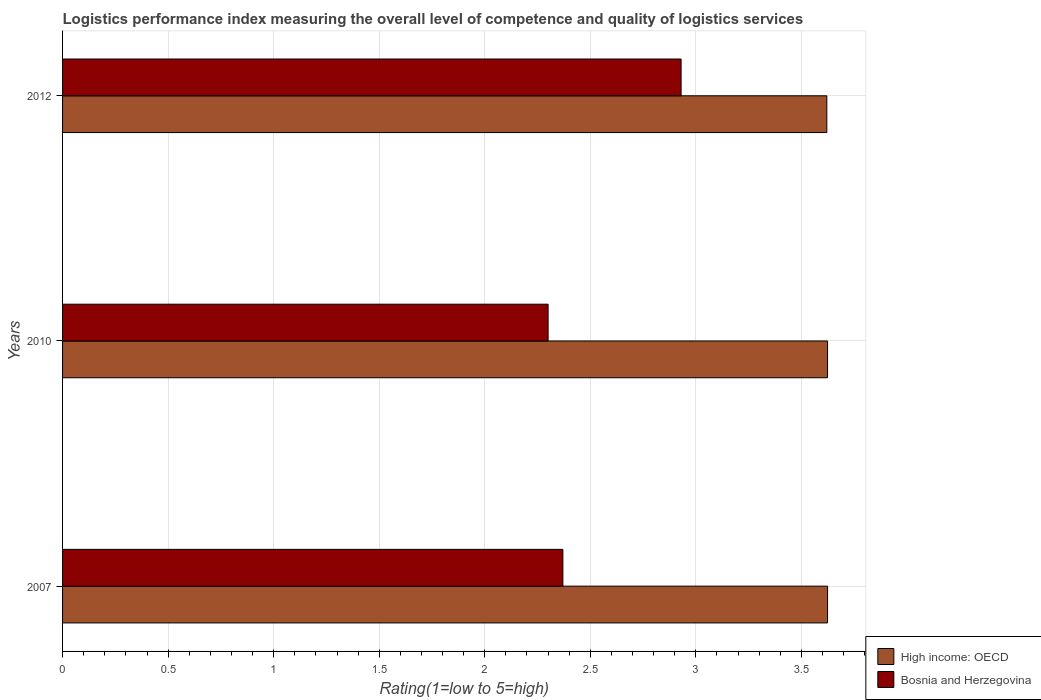Are the number of bars per tick equal to the number of legend labels?
Your answer should be very brief. Yes. What is the label of the 2nd group of bars from the top?
Give a very brief answer. 2010. What is the Logistic performance index in High income: OECD in 2007?
Your response must be concise. 3.62. Across all years, what is the maximum Logistic performance index in High income: OECD?
Give a very brief answer. 3.62. Across all years, what is the minimum Logistic performance index in Bosnia and Herzegovina?
Give a very brief answer. 2.3. What is the difference between the Logistic performance index in High income: OECD in 2010 and that in 2012?
Offer a terse response. 0. What is the difference between the Logistic performance index in Bosnia and Herzegovina in 2010 and the Logistic performance index in High income: OECD in 2007?
Keep it short and to the point. -1.32. What is the average Logistic performance index in Bosnia and Herzegovina per year?
Provide a succinct answer. 2.53. In the year 2010, what is the difference between the Logistic performance index in Bosnia and Herzegovina and Logistic performance index in High income: OECD?
Offer a terse response. -1.32. In how many years, is the Logistic performance index in Bosnia and Herzegovina greater than 3.1 ?
Provide a short and direct response. 0. What is the ratio of the Logistic performance index in High income: OECD in 2007 to that in 2010?
Provide a succinct answer. 1. Is the difference between the Logistic performance index in Bosnia and Herzegovina in 2010 and 2012 greater than the difference between the Logistic performance index in High income: OECD in 2010 and 2012?
Offer a very short reply. No. What is the difference between the highest and the second highest Logistic performance index in Bosnia and Herzegovina?
Make the answer very short. 0.56. What is the difference between the highest and the lowest Logistic performance index in High income: OECD?
Make the answer very short. 0. What does the 2nd bar from the top in 2012 represents?
Provide a succinct answer. High income: OECD. What does the 1st bar from the bottom in 2012 represents?
Provide a succinct answer. High income: OECD. Are all the bars in the graph horizontal?
Offer a very short reply. Yes. Does the graph contain grids?
Ensure brevity in your answer.  Yes. How are the legend labels stacked?
Your response must be concise. Vertical. What is the title of the graph?
Keep it short and to the point. Logistics performance index measuring the overall level of competence and quality of logistics services. What is the label or title of the X-axis?
Keep it short and to the point. Rating(1=low to 5=high). What is the Rating(1=low to 5=high) of High income: OECD in 2007?
Give a very brief answer. 3.62. What is the Rating(1=low to 5=high) of Bosnia and Herzegovina in 2007?
Ensure brevity in your answer.  2.37. What is the Rating(1=low to 5=high) in High income: OECD in 2010?
Provide a succinct answer. 3.62. What is the Rating(1=low to 5=high) in Bosnia and Herzegovina in 2010?
Provide a short and direct response. 2.3. What is the Rating(1=low to 5=high) of High income: OECD in 2012?
Offer a very short reply. 3.62. What is the Rating(1=low to 5=high) of Bosnia and Herzegovina in 2012?
Give a very brief answer. 2.93. Across all years, what is the maximum Rating(1=low to 5=high) of High income: OECD?
Keep it short and to the point. 3.62. Across all years, what is the maximum Rating(1=low to 5=high) in Bosnia and Herzegovina?
Your response must be concise. 2.93. Across all years, what is the minimum Rating(1=low to 5=high) of High income: OECD?
Offer a very short reply. 3.62. What is the total Rating(1=low to 5=high) in High income: OECD in the graph?
Keep it short and to the point. 10.87. What is the total Rating(1=low to 5=high) in Bosnia and Herzegovina in the graph?
Offer a very short reply. 7.6. What is the difference between the Rating(1=low to 5=high) in High income: OECD in 2007 and that in 2010?
Ensure brevity in your answer.  0. What is the difference between the Rating(1=low to 5=high) in Bosnia and Herzegovina in 2007 and that in 2010?
Your answer should be very brief. 0.07. What is the difference between the Rating(1=low to 5=high) in High income: OECD in 2007 and that in 2012?
Provide a short and direct response. 0. What is the difference between the Rating(1=low to 5=high) of Bosnia and Herzegovina in 2007 and that in 2012?
Ensure brevity in your answer.  -0.56. What is the difference between the Rating(1=low to 5=high) in High income: OECD in 2010 and that in 2012?
Provide a succinct answer. 0. What is the difference between the Rating(1=low to 5=high) in Bosnia and Herzegovina in 2010 and that in 2012?
Provide a short and direct response. -0.63. What is the difference between the Rating(1=low to 5=high) of High income: OECD in 2007 and the Rating(1=low to 5=high) of Bosnia and Herzegovina in 2010?
Your answer should be very brief. 1.32. What is the difference between the Rating(1=low to 5=high) in High income: OECD in 2007 and the Rating(1=low to 5=high) in Bosnia and Herzegovina in 2012?
Ensure brevity in your answer.  0.69. What is the difference between the Rating(1=low to 5=high) in High income: OECD in 2010 and the Rating(1=low to 5=high) in Bosnia and Herzegovina in 2012?
Provide a succinct answer. 0.69. What is the average Rating(1=low to 5=high) in High income: OECD per year?
Provide a succinct answer. 3.62. What is the average Rating(1=low to 5=high) in Bosnia and Herzegovina per year?
Ensure brevity in your answer.  2.53. In the year 2007, what is the difference between the Rating(1=low to 5=high) of High income: OECD and Rating(1=low to 5=high) of Bosnia and Herzegovina?
Offer a terse response. 1.25. In the year 2010, what is the difference between the Rating(1=low to 5=high) of High income: OECD and Rating(1=low to 5=high) of Bosnia and Herzegovina?
Offer a very short reply. 1.32. In the year 2012, what is the difference between the Rating(1=low to 5=high) of High income: OECD and Rating(1=low to 5=high) of Bosnia and Herzegovina?
Offer a very short reply. 0.69. What is the ratio of the Rating(1=low to 5=high) of High income: OECD in 2007 to that in 2010?
Your answer should be very brief. 1. What is the ratio of the Rating(1=low to 5=high) in Bosnia and Herzegovina in 2007 to that in 2010?
Your response must be concise. 1.03. What is the ratio of the Rating(1=low to 5=high) of High income: OECD in 2007 to that in 2012?
Offer a terse response. 1. What is the ratio of the Rating(1=low to 5=high) of Bosnia and Herzegovina in 2007 to that in 2012?
Provide a succinct answer. 0.81. What is the ratio of the Rating(1=low to 5=high) of High income: OECD in 2010 to that in 2012?
Offer a very short reply. 1. What is the ratio of the Rating(1=low to 5=high) in Bosnia and Herzegovina in 2010 to that in 2012?
Your answer should be compact. 0.79. What is the difference between the highest and the second highest Rating(1=low to 5=high) in Bosnia and Herzegovina?
Ensure brevity in your answer.  0.56. What is the difference between the highest and the lowest Rating(1=low to 5=high) of High income: OECD?
Offer a very short reply. 0. What is the difference between the highest and the lowest Rating(1=low to 5=high) in Bosnia and Herzegovina?
Your answer should be compact. 0.63. 